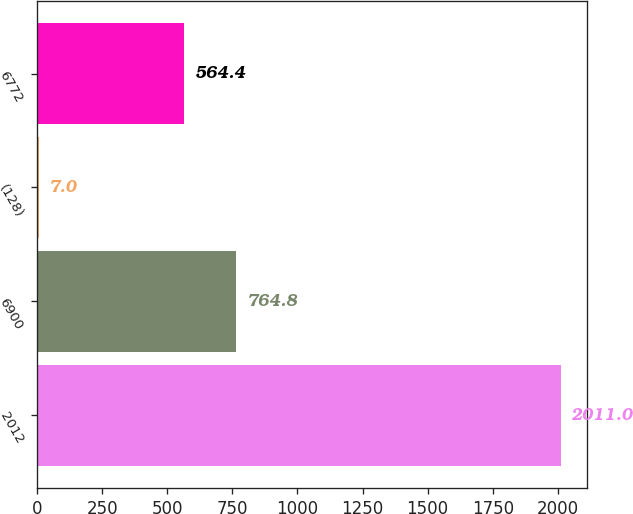Convert chart to OTSL. <chart><loc_0><loc_0><loc_500><loc_500><bar_chart><fcel>2012<fcel>6900<fcel>(128)<fcel>6772<nl><fcel>2011<fcel>764.8<fcel>7<fcel>564.4<nl></chart> 